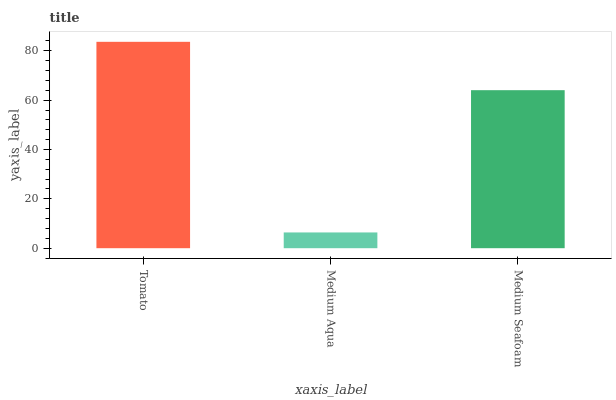Is Medium Aqua the minimum?
Answer yes or no. Yes. Is Tomato the maximum?
Answer yes or no. Yes. Is Medium Seafoam the minimum?
Answer yes or no. No. Is Medium Seafoam the maximum?
Answer yes or no. No. Is Medium Seafoam greater than Medium Aqua?
Answer yes or no. Yes. Is Medium Aqua less than Medium Seafoam?
Answer yes or no. Yes. Is Medium Aqua greater than Medium Seafoam?
Answer yes or no. No. Is Medium Seafoam less than Medium Aqua?
Answer yes or no. No. Is Medium Seafoam the high median?
Answer yes or no. Yes. Is Medium Seafoam the low median?
Answer yes or no. Yes. Is Tomato the high median?
Answer yes or no. No. Is Medium Aqua the low median?
Answer yes or no. No. 